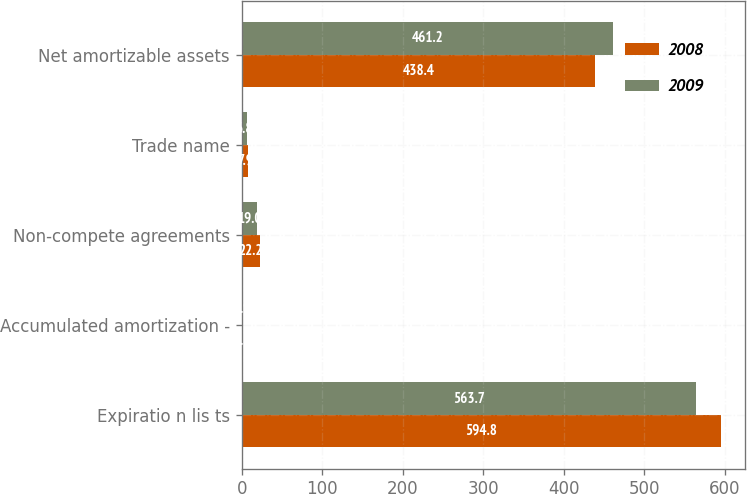Convert chart to OTSL. <chart><loc_0><loc_0><loc_500><loc_500><stacked_bar_chart><ecel><fcel>Expiratio n lis ts<fcel>Accumulated amortization -<fcel>Non-compete agreements<fcel>Trade name<fcel>Net amortizable assets<nl><fcel>2008<fcel>594.8<fcel>1.5<fcel>22.2<fcel>7.9<fcel>438.4<nl><fcel>2009<fcel>563.7<fcel>0.9<fcel>19<fcel>6.8<fcel>461.2<nl></chart> 